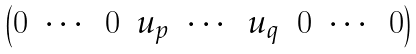Convert formula to latex. <formula><loc_0><loc_0><loc_500><loc_500>\begin{pmatrix} 0 & \cdots & 0 & u _ { p } & \cdots & u _ { q } & 0 & \cdots & 0 \end{pmatrix}</formula> 